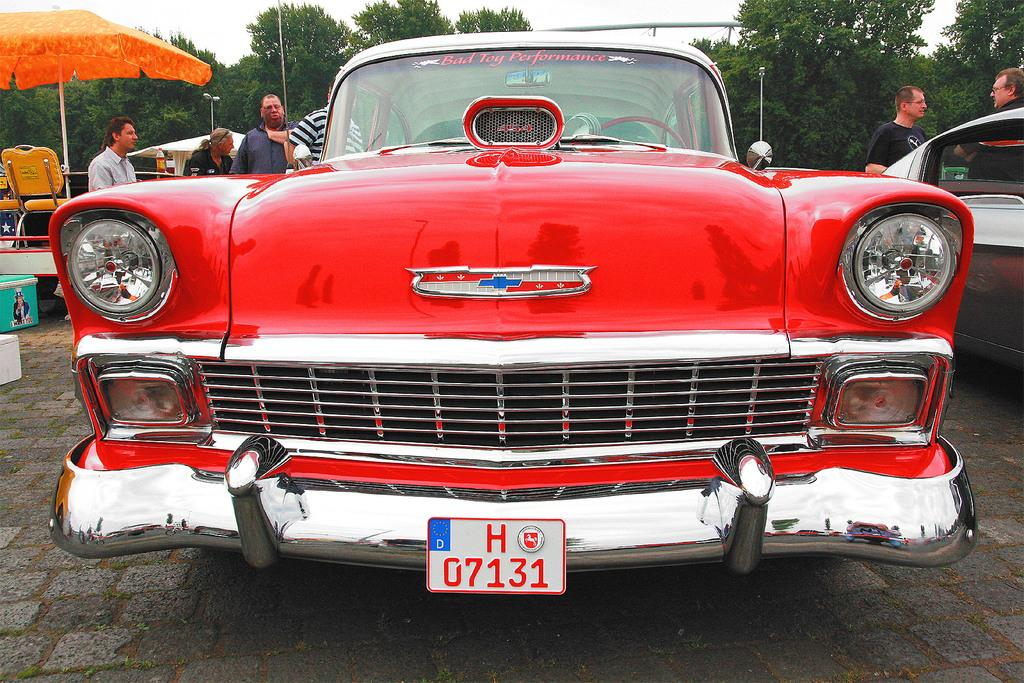What type of vehicles can be seen in the image? There are cars in the image. What are the people in the image doing? There are people standing in the image. What object is on the left side of the image? There is a parasol on the left side of the image. What type of furniture is on the left side of the image? There are chairs on the left side of the image. What can be seen in the background of the image? There are trees, poles, sheds, and the sky visible in the background of the image. How many cows are grazing in the background of the image? There are no cows present in the image. What type of gold ornament is hanging from the parasol in the image? There is no gold ornament present on the parasol in the image. 